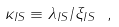<formula> <loc_0><loc_0><loc_500><loc_500>\kappa _ { I S } \equiv \lambda _ { I S } / \xi _ { I S } \ ,</formula> 